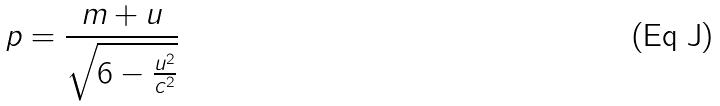Convert formula to latex. <formula><loc_0><loc_0><loc_500><loc_500>p = \frac { m + u } { \sqrt { 6 - \frac { u ^ { 2 } } { c ^ { 2 } } } }</formula> 